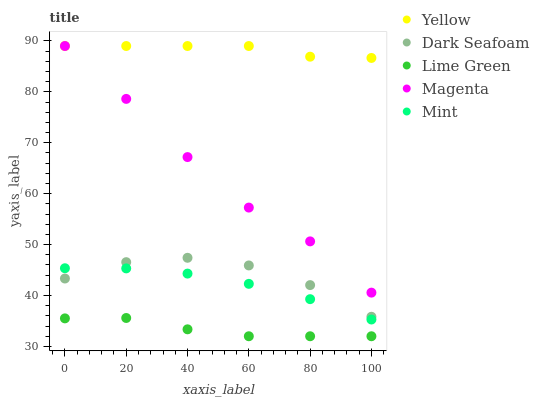Does Lime Green have the minimum area under the curve?
Answer yes or no. Yes. Does Yellow have the maximum area under the curve?
Answer yes or no. Yes. Does Dark Seafoam have the minimum area under the curve?
Answer yes or no. No. Does Dark Seafoam have the maximum area under the curve?
Answer yes or no. No. Is Yellow the smoothest?
Answer yes or no. Yes. Is Dark Seafoam the roughest?
Answer yes or no. Yes. Is Lime Green the smoothest?
Answer yes or no. No. Is Lime Green the roughest?
Answer yes or no. No. Does Lime Green have the lowest value?
Answer yes or no. Yes. Does Dark Seafoam have the lowest value?
Answer yes or no. No. Does Yellow have the highest value?
Answer yes or no. Yes. Does Dark Seafoam have the highest value?
Answer yes or no. No. Is Lime Green less than Magenta?
Answer yes or no. Yes. Is Yellow greater than Lime Green?
Answer yes or no. Yes. Does Yellow intersect Magenta?
Answer yes or no. Yes. Is Yellow less than Magenta?
Answer yes or no. No. Is Yellow greater than Magenta?
Answer yes or no. No. Does Lime Green intersect Magenta?
Answer yes or no. No. 